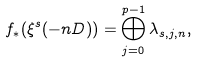Convert formula to latex. <formula><loc_0><loc_0><loc_500><loc_500>f _ { * } ( \xi ^ { s } ( - n D ) ) = \bigoplus ^ { p - 1 } _ { j = 0 } \lambda _ { s , j , n } ,</formula> 